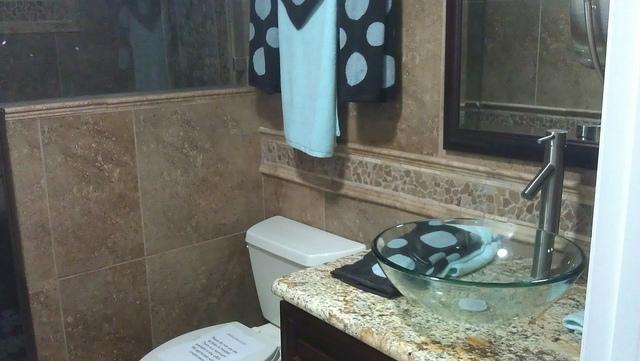How many toilets are visible?
Give a very brief answer. 1. How many horses are there?
Give a very brief answer. 0. 